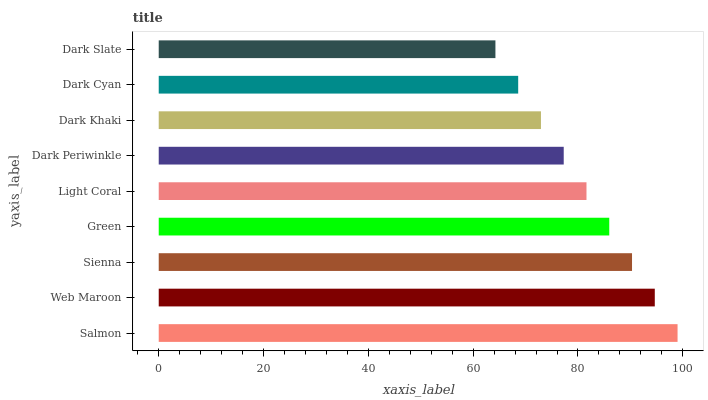Is Dark Slate the minimum?
Answer yes or no. Yes. Is Salmon the maximum?
Answer yes or no. Yes. Is Web Maroon the minimum?
Answer yes or no. No. Is Web Maroon the maximum?
Answer yes or no. No. Is Salmon greater than Web Maroon?
Answer yes or no. Yes. Is Web Maroon less than Salmon?
Answer yes or no. Yes. Is Web Maroon greater than Salmon?
Answer yes or no. No. Is Salmon less than Web Maroon?
Answer yes or no. No. Is Light Coral the high median?
Answer yes or no. Yes. Is Light Coral the low median?
Answer yes or no. Yes. Is Sienna the high median?
Answer yes or no. No. Is Dark Cyan the low median?
Answer yes or no. No. 